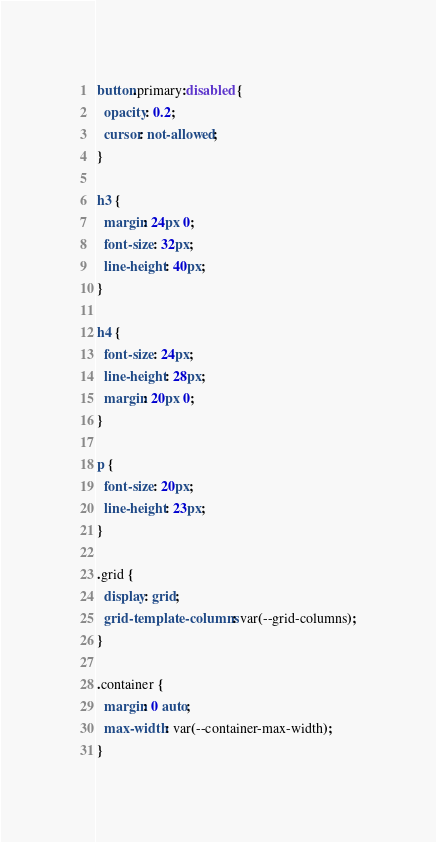<code> <loc_0><loc_0><loc_500><loc_500><_CSS_>
button.primary:disabled {
  opacity: 0.2;
  cursor: not-allowed;
}

h3 {
  margin: 24px 0;
  font-size: 32px;
  line-height: 40px;
}

h4 {
  font-size: 24px;
  line-height: 28px;
  margin: 20px 0;
}

p {
  font-size: 20px;
  line-height: 23px;
}

.grid {
  display: grid;
  grid-template-columns: var(--grid-columns);
}

.container {
  margin: 0 auto;
  max-width: var(--container-max-width);
}
</code> 